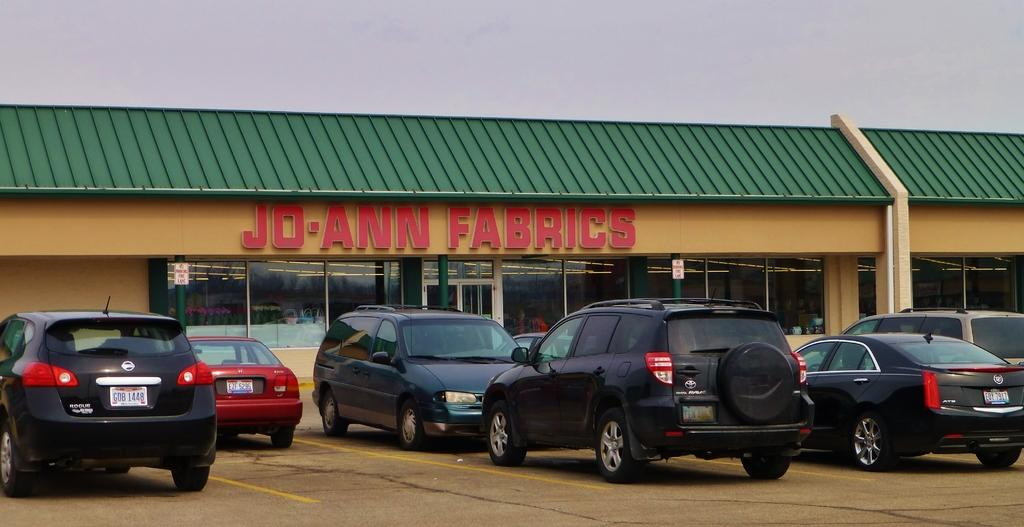What type of establishment is depicted in the image? There is a store in the image. What features can be seen on the store's exterior? The store has a roof, windows, and doors. What is parked in front of the store? There are vehicles parked in front of the store. What can be seen at the top of the image? The sky is visible at the top of the image. Where is the desk located in the image? There is no desk present in the image. What type of support is the store leaning on in the image? The store is not leaning on any support in the image; it is a freestanding building. 